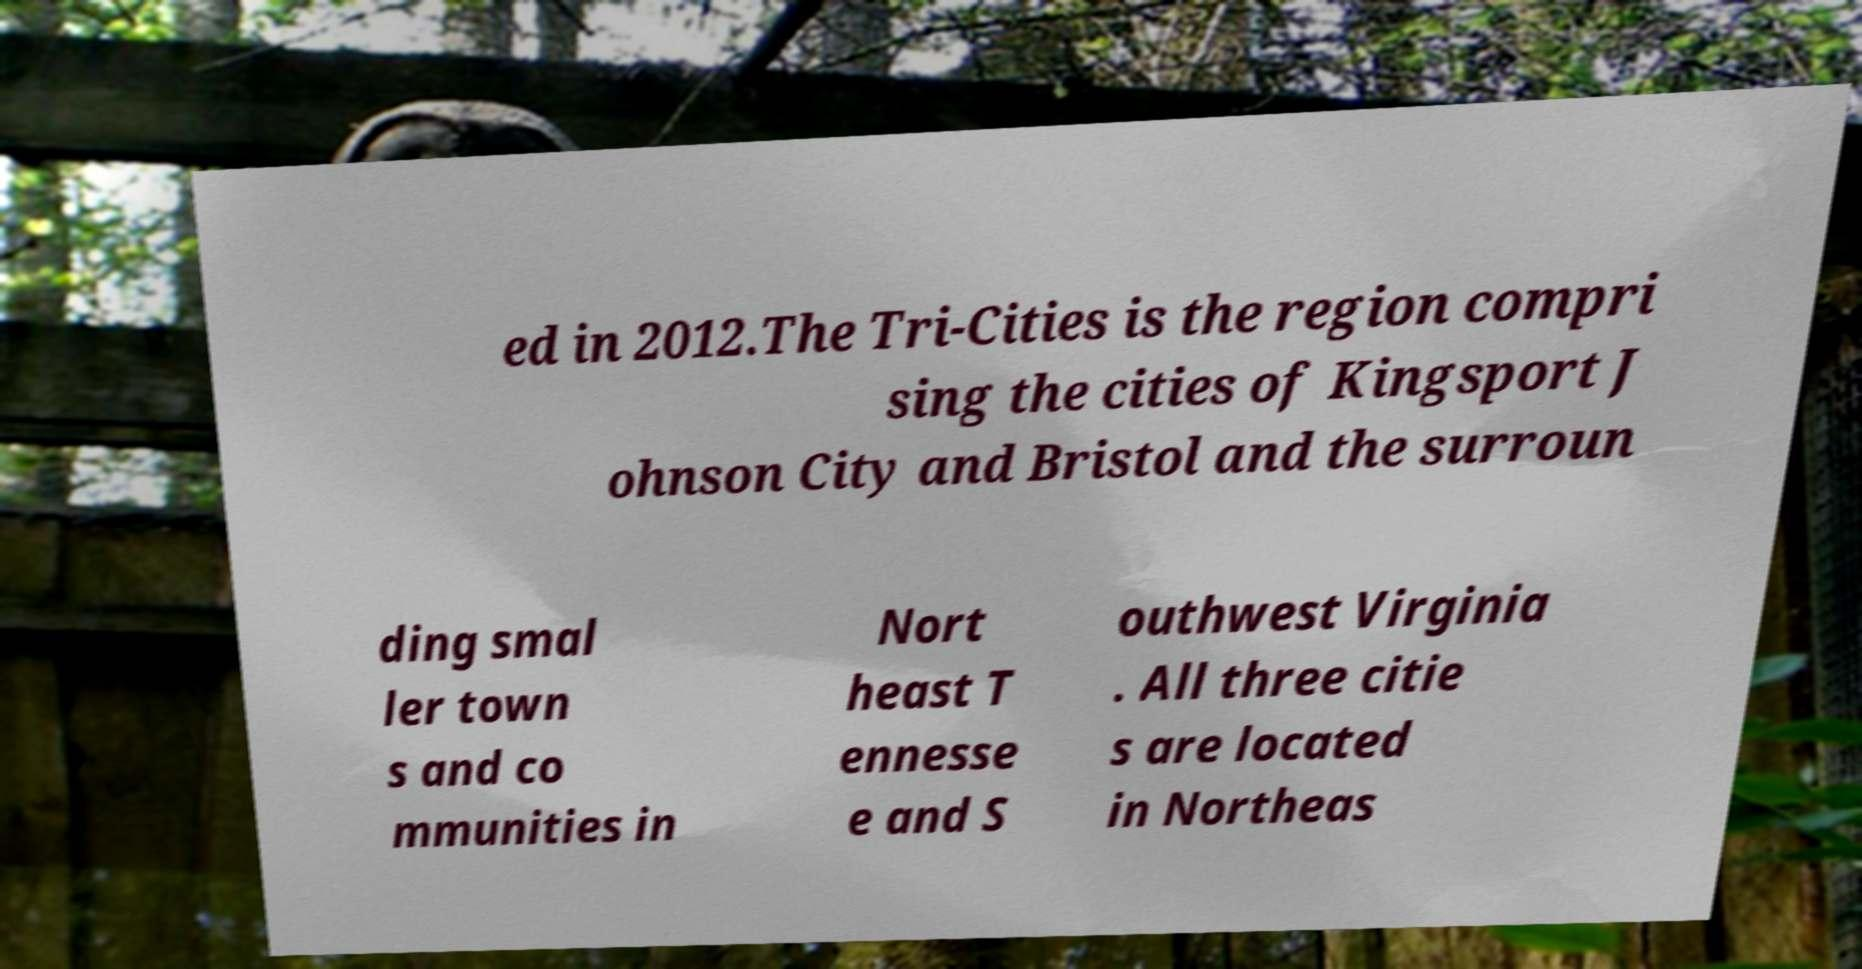Could you assist in decoding the text presented in this image and type it out clearly? ed in 2012.The Tri-Cities is the region compri sing the cities of Kingsport J ohnson City and Bristol and the surroun ding smal ler town s and co mmunities in Nort heast T ennesse e and S outhwest Virginia . All three citie s are located in Northeas 